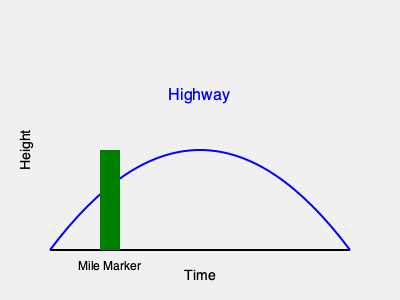In Bob Dylan's "Highway 61 Revisited," the highway is often interpreted as a metaphor for life's journey. How does this visual representation reflect the poetic elements used in Dylan's lyrics, particularly in relation to time and personal growth? 1. The graph represents a highway as a curved line, symbolizing life's journey in Dylan's lyrics.
2. The x-axis represents time, a common element in Dylan's narrative style, showing progression through life.
3. The y-axis represents height or personal growth, reflecting the ups and downs of experiences described in Dylan's songs.
4. The curve of the highway (blue line) shows that life's journey is not linear, but has highs and lows, mirroring Dylan's use of contrasting imagery and emotions.
5. The mile marker (green rectangle) represents significant events or milestones in life, often marked by pivotal moments in Dylan's lyrics.
6. The overall upward trend of the curve suggests hope and progress, a theme often present in Dylan's more optimistic works.
7. The open-ended nature of the curve implies an ongoing journey, reflecting Dylan's tendency to leave interpretations open-ended in his lyrics.

This visual metaphor encapsulates Dylan's poetic approach of using concrete imagery (like highways) to represent abstract concepts (like life's journey), while also capturing the sense of movement, time, and personal growth prevalent in his work.
Answer: Nonlinear journey through time and growth 